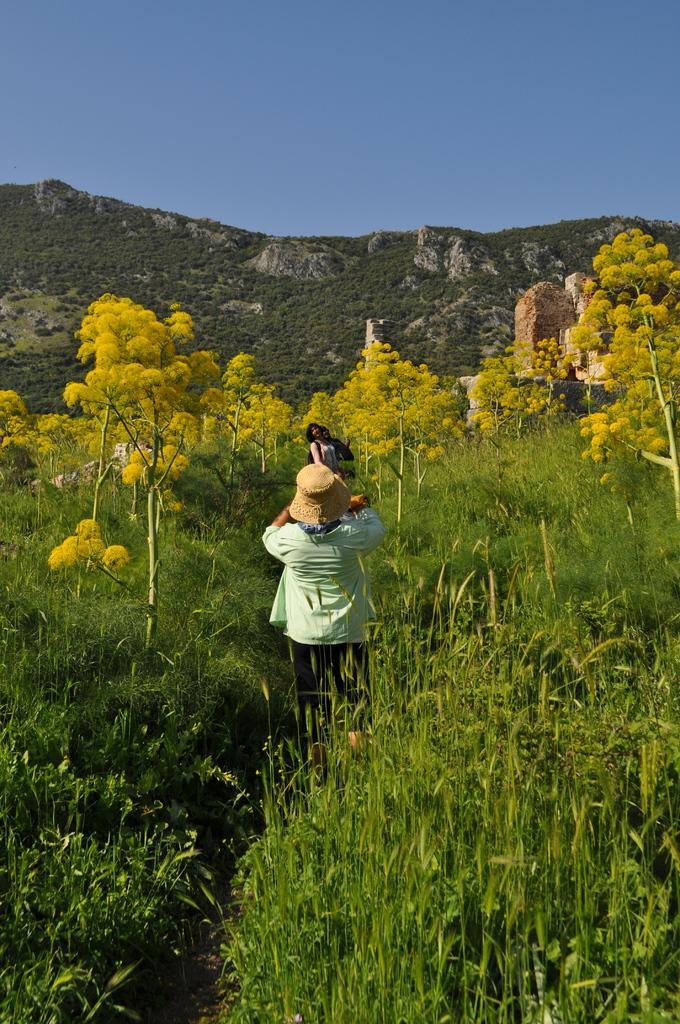Please provide a concise description of this image. In this picture I can see few people standing. There are plants, trees, rocks, hill, and in the background there is the sky. 